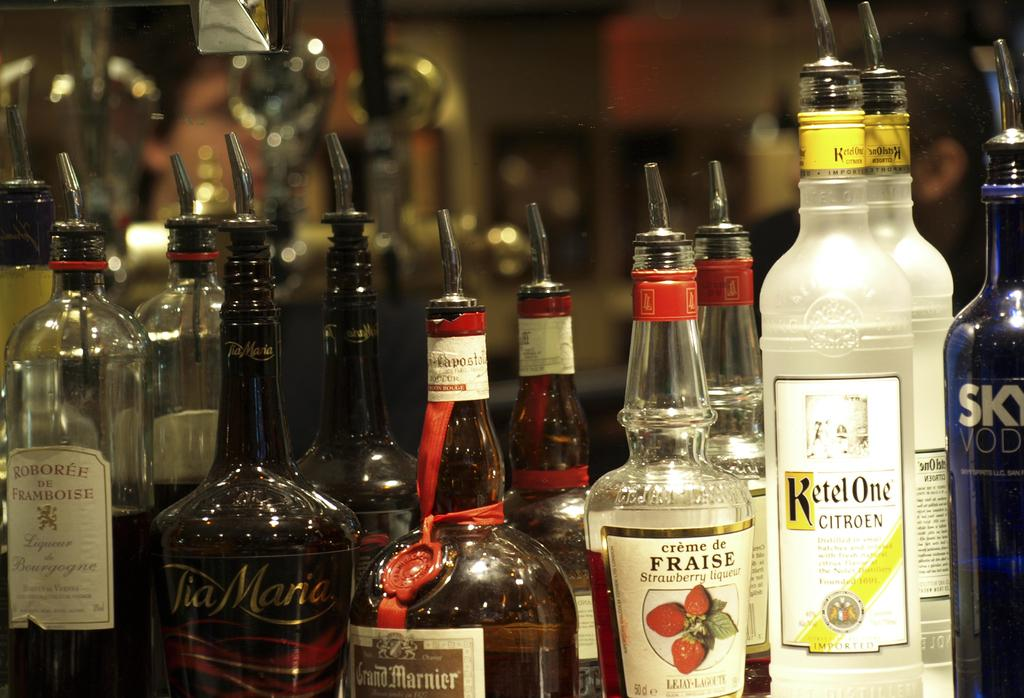<image>
Offer a succinct explanation of the picture presented. Many bottles of alcohol including one that says "KETEL ONE". 